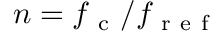<formula> <loc_0><loc_0><loc_500><loc_500>n = f _ { c } / f _ { r e f }</formula> 